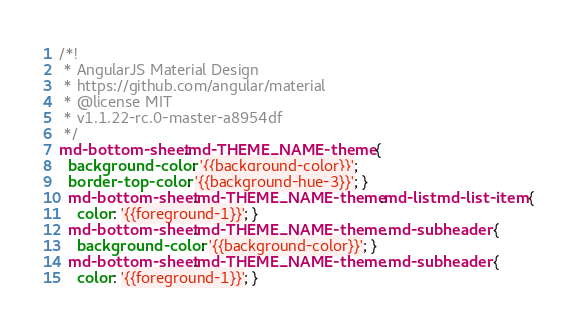<code> <loc_0><loc_0><loc_500><loc_500><_CSS_>/*!
 * AngularJS Material Design
 * https://github.com/angular/material
 * @license MIT
 * v1.1.22-rc.0-master-a8954df
 */
md-bottom-sheet.md-THEME_NAME-theme {
  background-color: '{{background-color}}';
  border-top-color: '{{background-hue-3}}'; }
  md-bottom-sheet.md-THEME_NAME-theme.md-list md-list-item {
    color: '{{foreground-1}}'; }
  md-bottom-sheet.md-THEME_NAME-theme .md-subheader {
    background-color: '{{background-color}}'; }
  md-bottom-sheet.md-THEME_NAME-theme .md-subheader {
    color: '{{foreground-1}}'; }
</code> 